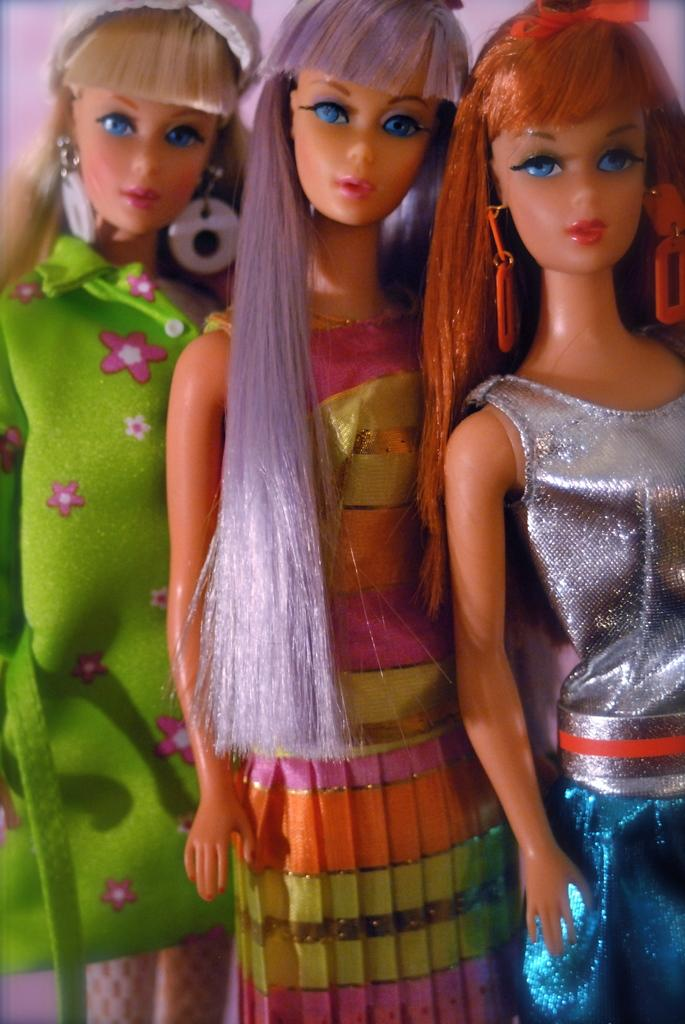How many dolls are present in the image? There are three Barbie dolls in the image. What type of bells can be heard ringing in the background of the image? There are no bells present in the image, and therefore no sound can be heard. 